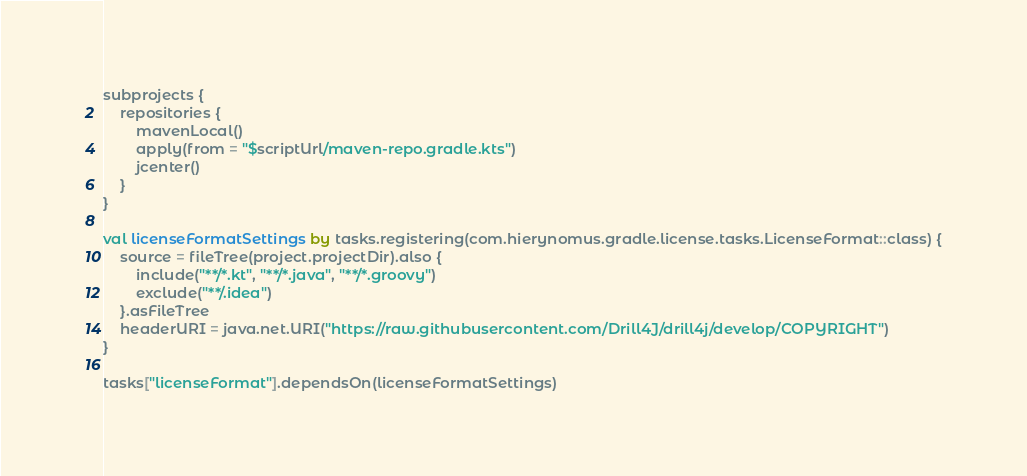<code> <loc_0><loc_0><loc_500><loc_500><_Kotlin_>subprojects {
    repositories {
        mavenLocal()
        apply(from = "$scriptUrl/maven-repo.gradle.kts")
        jcenter()
    }
}

val licenseFormatSettings by tasks.registering(com.hierynomus.gradle.license.tasks.LicenseFormat::class) {
    source = fileTree(project.projectDir).also {
        include("**/*.kt", "**/*.java", "**/*.groovy")
        exclude("**/.idea")
    }.asFileTree
    headerURI = java.net.URI("https://raw.githubusercontent.com/Drill4J/drill4j/develop/COPYRIGHT")
}

tasks["licenseFormat"].dependsOn(licenseFormatSettings)
</code> 